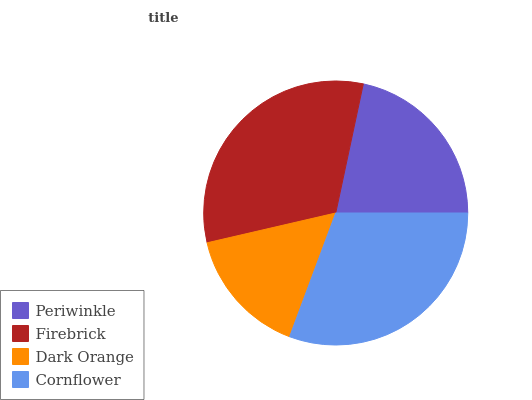Is Dark Orange the minimum?
Answer yes or no. Yes. Is Firebrick the maximum?
Answer yes or no. Yes. Is Firebrick the minimum?
Answer yes or no. No. Is Dark Orange the maximum?
Answer yes or no. No. Is Firebrick greater than Dark Orange?
Answer yes or no. Yes. Is Dark Orange less than Firebrick?
Answer yes or no. Yes. Is Dark Orange greater than Firebrick?
Answer yes or no. No. Is Firebrick less than Dark Orange?
Answer yes or no. No. Is Cornflower the high median?
Answer yes or no. Yes. Is Periwinkle the low median?
Answer yes or no. Yes. Is Firebrick the high median?
Answer yes or no. No. Is Dark Orange the low median?
Answer yes or no. No. 